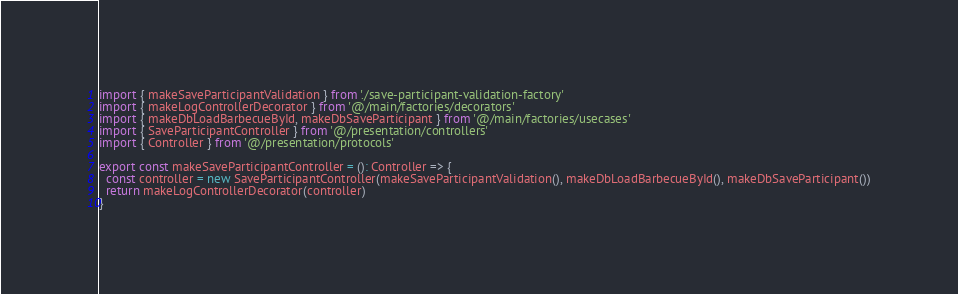<code> <loc_0><loc_0><loc_500><loc_500><_TypeScript_>import { makeSaveParticipantValidation } from './save-participant-validation-factory'
import { makeLogControllerDecorator } from '@/main/factories/decorators'
import { makeDbLoadBarbecueById, makeDbSaveParticipant } from '@/main/factories/usecases'
import { SaveParticipantController } from '@/presentation/controllers'
import { Controller } from '@/presentation/protocols'

export const makeSaveParticipantController = (): Controller => {
  const controller = new SaveParticipantController(makeSaveParticipantValidation(), makeDbLoadBarbecueById(), makeDbSaveParticipant())
  return makeLogControllerDecorator(controller)
}
</code> 